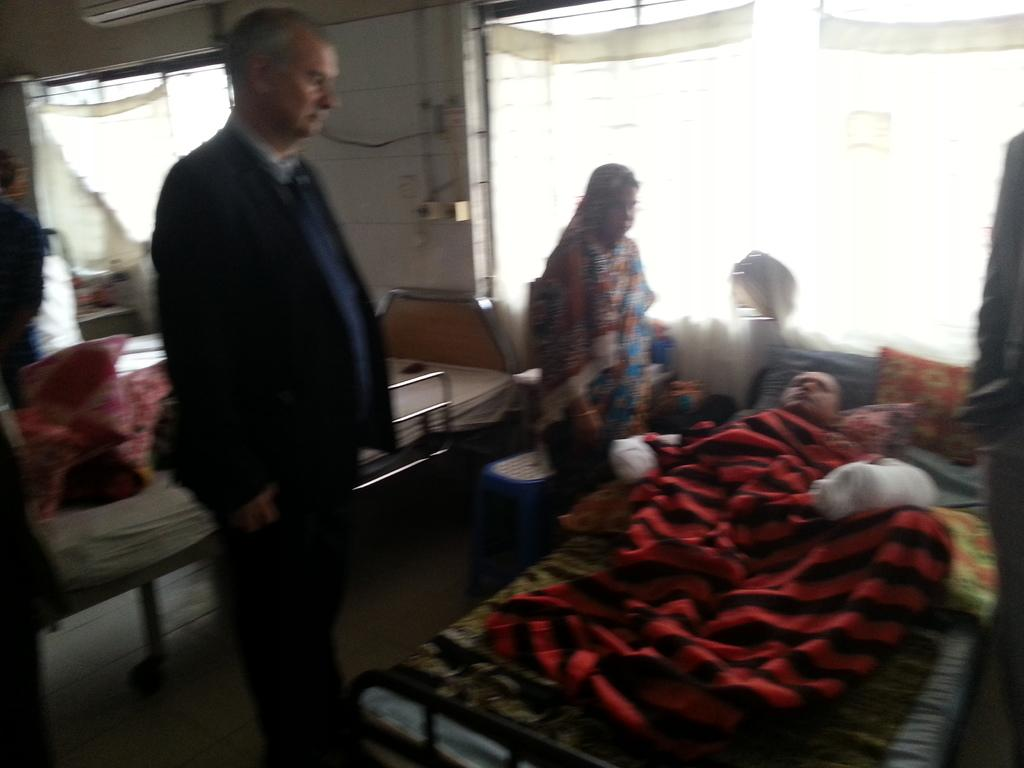What type of furniture is present in the image? There are beds in the image. Are there any people in the image? Yes, there are people in the image. Can you describe the position of one person in the image? One person is on a bed on the right side of the image. How would you describe the quality of the image? The image is slightly blurry. What type of pizzas are being served by the manager in the image? There is no manager or pizzas present in the image. How does the snow affect the visibility of the people in the image? There is no snow present in the image, so it does not affect the visibility of the people. 